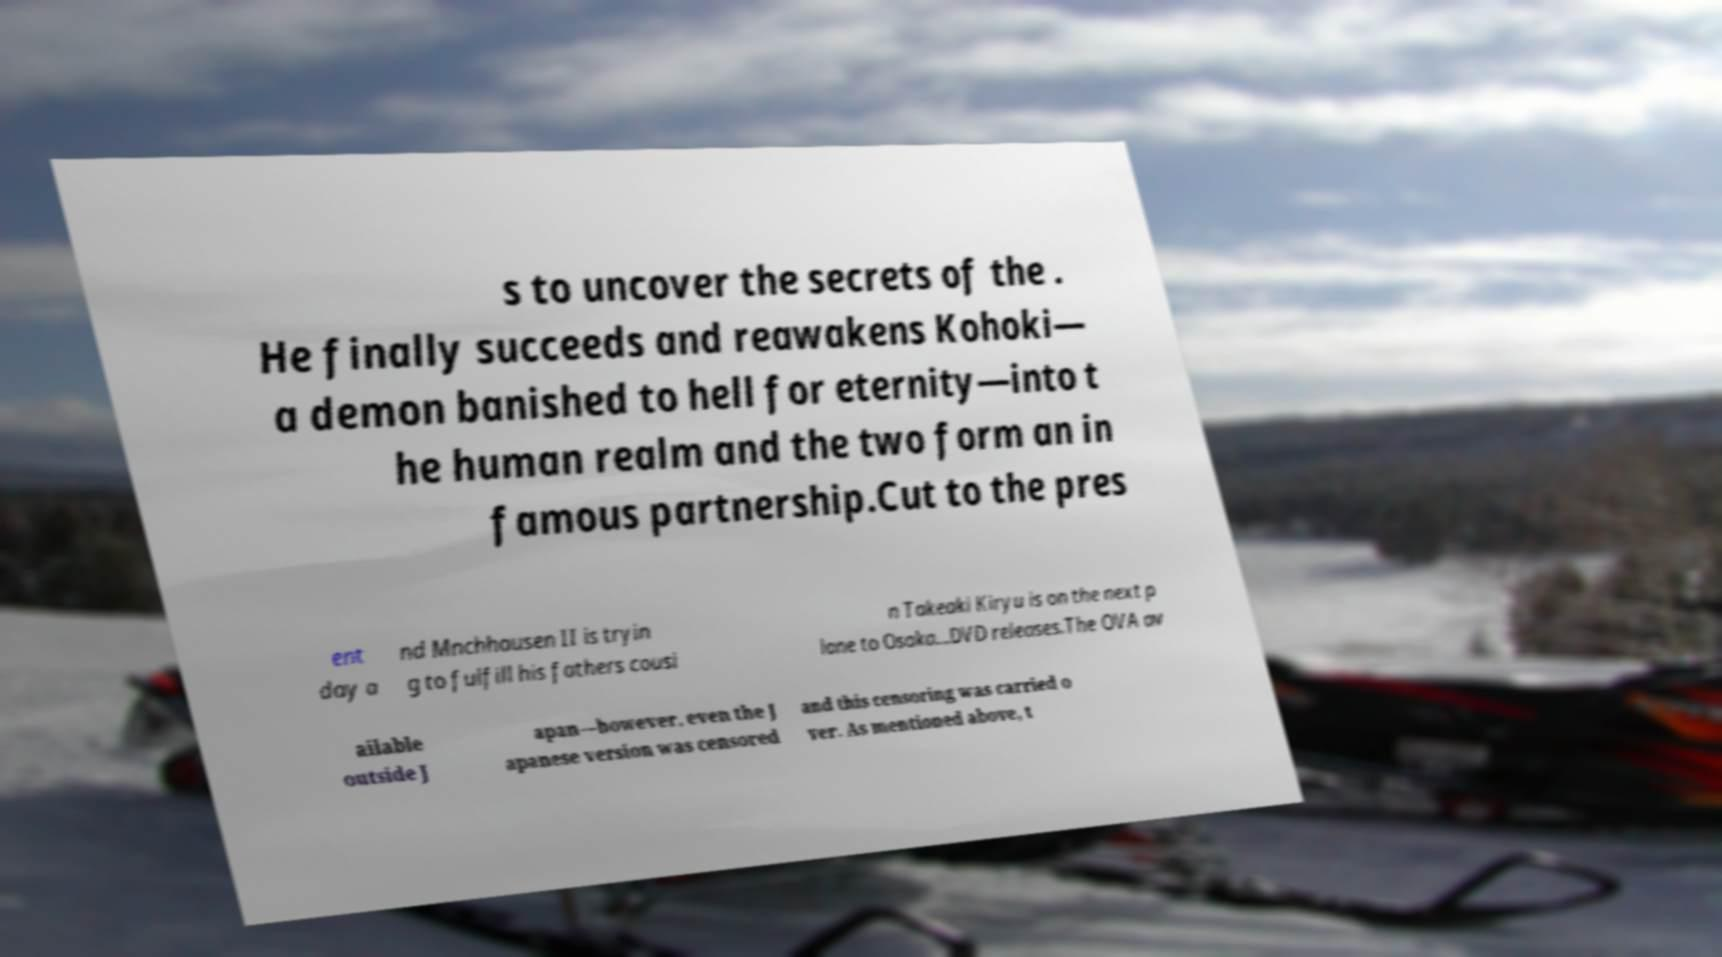Can you accurately transcribe the text from the provided image for me? s to uncover the secrets of the . He finally succeeds and reawakens Kohoki— a demon banished to hell for eternity—into t he human realm and the two form an in famous partnership.Cut to the pres ent day a nd Mnchhausen II is tryin g to fulfill his fathers cousi n Takeaki Kiryu is on the next p lane to Osaka...DVD releases.The OVA av ailable outside J apan—however, even the J apanese version was censored and this censoring was carried o ver. As mentioned above, t 